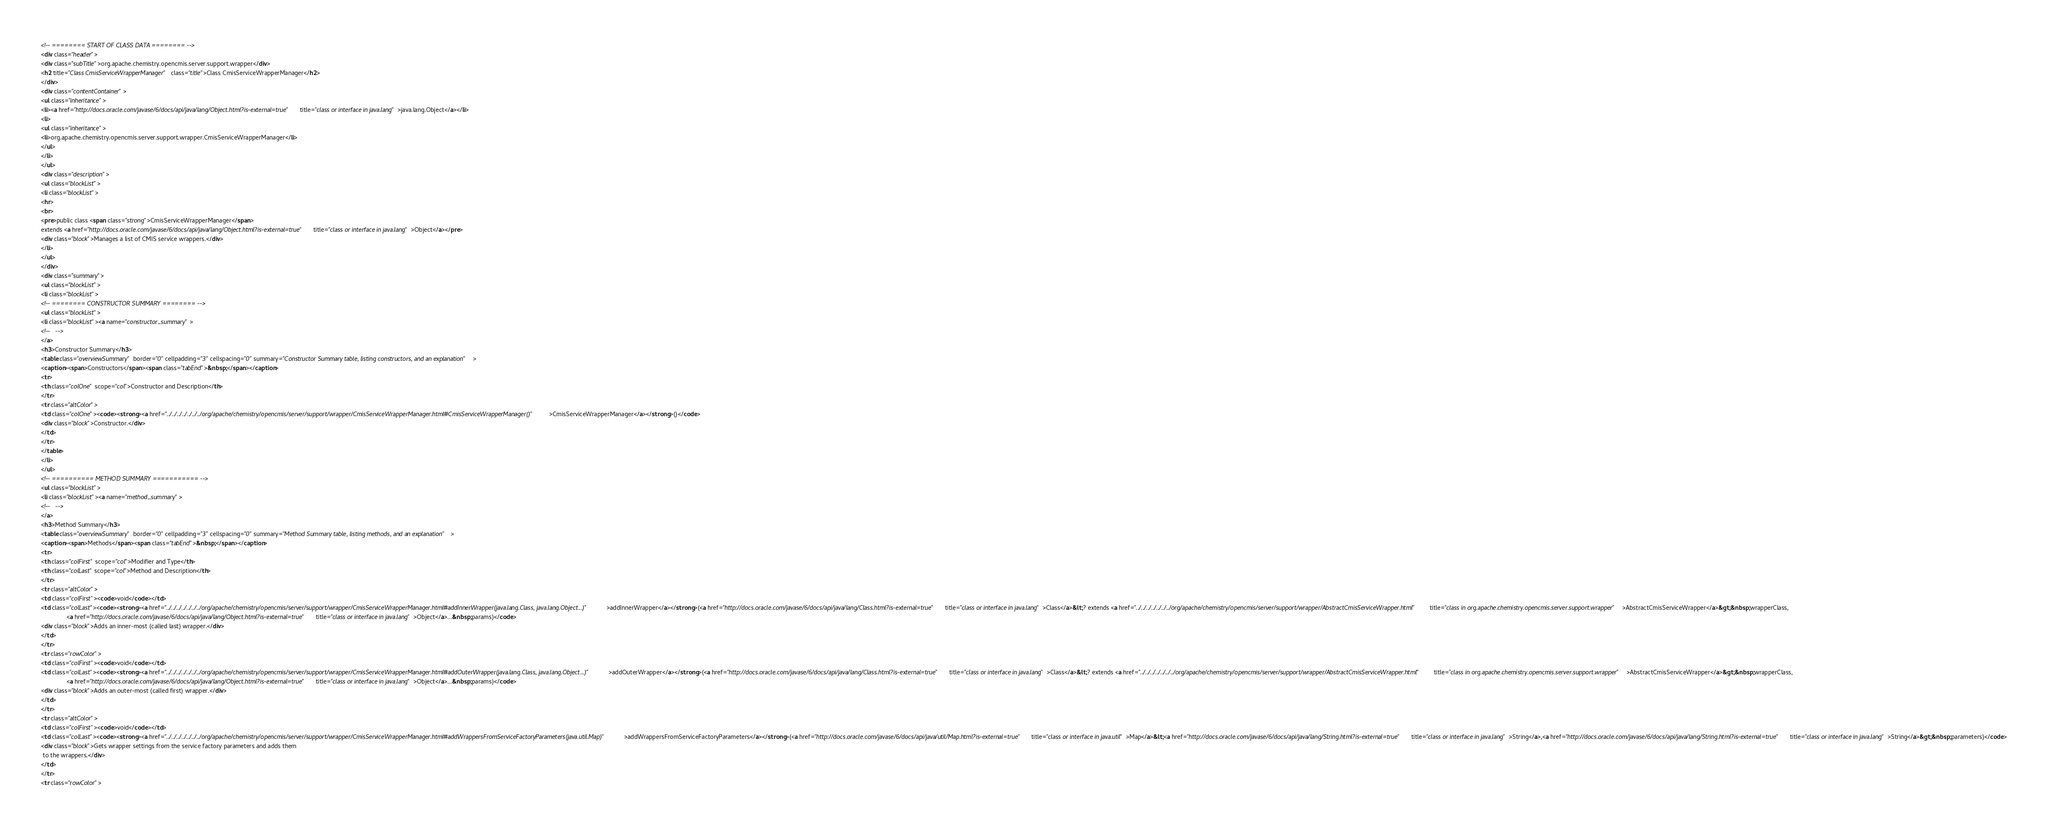<code> <loc_0><loc_0><loc_500><loc_500><_HTML_><!-- ======== START OF CLASS DATA ======== -->
<div class="header">
<div class="subTitle">org.apache.chemistry.opencmis.server.support.wrapper</div>
<h2 title="Class CmisServiceWrapperManager" class="title">Class CmisServiceWrapperManager</h2>
</div>
<div class="contentContainer">
<ul class="inheritance">
<li><a href="http://docs.oracle.com/javase/6/docs/api/java/lang/Object.html?is-external=true" title="class or interface in java.lang">java.lang.Object</a></li>
<li>
<ul class="inheritance">
<li>org.apache.chemistry.opencmis.server.support.wrapper.CmisServiceWrapperManager</li>
</ul>
</li>
</ul>
<div class="description">
<ul class="blockList">
<li class="blockList">
<hr>
<br>
<pre>public class <span class="strong">CmisServiceWrapperManager</span>
extends <a href="http://docs.oracle.com/javase/6/docs/api/java/lang/Object.html?is-external=true" title="class or interface in java.lang">Object</a></pre>
<div class="block">Manages a list of CMIS service wrappers.</div>
</li>
</ul>
</div>
<div class="summary">
<ul class="blockList">
<li class="blockList">
<!-- ======== CONSTRUCTOR SUMMARY ======== -->
<ul class="blockList">
<li class="blockList"><a name="constructor_summary">
<!--   -->
</a>
<h3>Constructor Summary</h3>
<table class="overviewSummary" border="0" cellpadding="3" cellspacing="0" summary="Constructor Summary table, listing constructors, and an explanation">
<caption><span>Constructors</span><span class="tabEnd">&nbsp;</span></caption>
<tr>
<th class="colOne" scope="col">Constructor and Description</th>
</tr>
<tr class="altColor">
<td class="colOne"><code><strong><a href="../../../../../../../org/apache/chemistry/opencmis/server/support/wrapper/CmisServiceWrapperManager.html#CmisServiceWrapperManager()">CmisServiceWrapperManager</a></strong>()</code>
<div class="block">Constructor.</div>
</td>
</tr>
</table>
</li>
</ul>
<!-- ========== METHOD SUMMARY =========== -->
<ul class="blockList">
<li class="blockList"><a name="method_summary">
<!--   -->
</a>
<h3>Method Summary</h3>
<table class="overviewSummary" border="0" cellpadding="3" cellspacing="0" summary="Method Summary table, listing methods, and an explanation">
<caption><span>Methods</span><span class="tabEnd">&nbsp;</span></caption>
<tr>
<th class="colFirst" scope="col">Modifier and Type</th>
<th class="colLast" scope="col">Method and Description</th>
</tr>
<tr class="altColor">
<td class="colFirst"><code>void</code></td>
<td class="colLast"><code><strong><a href="../../../../../../../org/apache/chemistry/opencmis/server/support/wrapper/CmisServiceWrapperManager.html#addInnerWrapper(java.lang.Class, java.lang.Object...)">addInnerWrapper</a></strong>(<a href="http://docs.oracle.com/javase/6/docs/api/java/lang/Class.html?is-external=true" title="class or interface in java.lang">Class</a>&lt;? extends <a href="../../../../../../../org/apache/chemistry/opencmis/server/support/wrapper/AbstractCmisServiceWrapper.html" title="class in org.apache.chemistry.opencmis.server.support.wrapper">AbstractCmisServiceWrapper</a>&gt;&nbsp;wrapperClass,
               <a href="http://docs.oracle.com/javase/6/docs/api/java/lang/Object.html?is-external=true" title="class or interface in java.lang">Object</a>...&nbsp;params)</code>
<div class="block">Adds an inner-most (called last) wrapper.</div>
</td>
</tr>
<tr class="rowColor">
<td class="colFirst"><code>void</code></td>
<td class="colLast"><code><strong><a href="../../../../../../../org/apache/chemistry/opencmis/server/support/wrapper/CmisServiceWrapperManager.html#addOuterWrapper(java.lang.Class, java.lang.Object...)">addOuterWrapper</a></strong>(<a href="http://docs.oracle.com/javase/6/docs/api/java/lang/Class.html?is-external=true" title="class or interface in java.lang">Class</a>&lt;? extends <a href="../../../../../../../org/apache/chemistry/opencmis/server/support/wrapper/AbstractCmisServiceWrapper.html" title="class in org.apache.chemistry.opencmis.server.support.wrapper">AbstractCmisServiceWrapper</a>&gt;&nbsp;wrapperClass,
               <a href="http://docs.oracle.com/javase/6/docs/api/java/lang/Object.html?is-external=true" title="class or interface in java.lang">Object</a>...&nbsp;params)</code>
<div class="block">Adds an outer-most (called first) wrapper.</div>
</td>
</tr>
<tr class="altColor">
<td class="colFirst"><code>void</code></td>
<td class="colLast"><code><strong><a href="../../../../../../../org/apache/chemistry/opencmis/server/support/wrapper/CmisServiceWrapperManager.html#addWrappersFromServiceFactoryParameters(java.util.Map)">addWrappersFromServiceFactoryParameters</a></strong>(<a href="http://docs.oracle.com/javase/6/docs/api/java/util/Map.html?is-external=true" title="class or interface in java.util">Map</a>&lt;<a href="http://docs.oracle.com/javase/6/docs/api/java/lang/String.html?is-external=true" title="class or interface in java.lang">String</a>,<a href="http://docs.oracle.com/javase/6/docs/api/java/lang/String.html?is-external=true" title="class or interface in java.lang">String</a>&gt;&nbsp;parameters)</code>
<div class="block">Gets wrapper settings from the service factory parameters and adds them
 to the wrappers.</div>
</td>
</tr>
<tr class="rowColor"></code> 